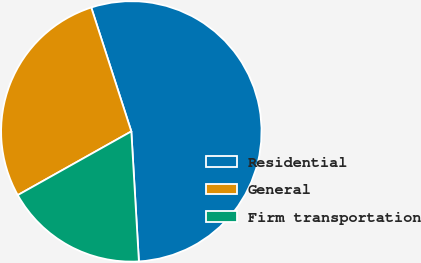<chart> <loc_0><loc_0><loc_500><loc_500><pie_chart><fcel>Residential<fcel>General<fcel>Firm transportation<nl><fcel>54.05%<fcel>28.16%<fcel>17.79%<nl></chart> 